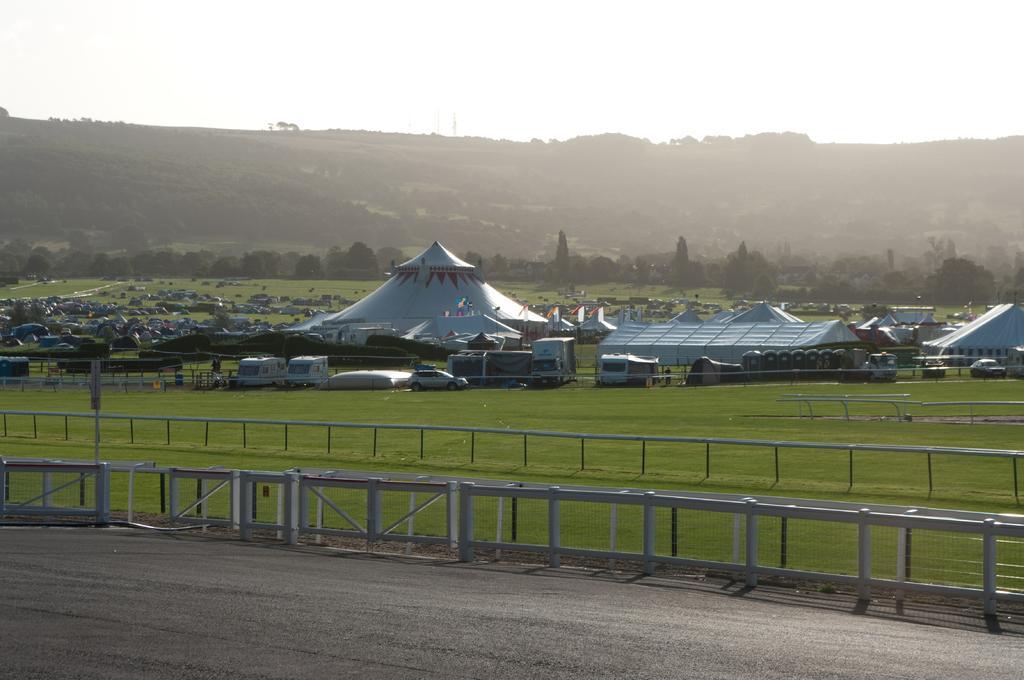How would you summarize this image in a sentence or two? These are the tents. I can see few vehicles, which are parked. I think this is a fence. Here is the grass. I can see the houses. These are the trees. This looks like a hill. This is the sky. At the bottom of the image, I can see the road. 